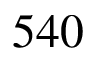<formula> <loc_0><loc_0><loc_500><loc_500>5 4 0</formula> 